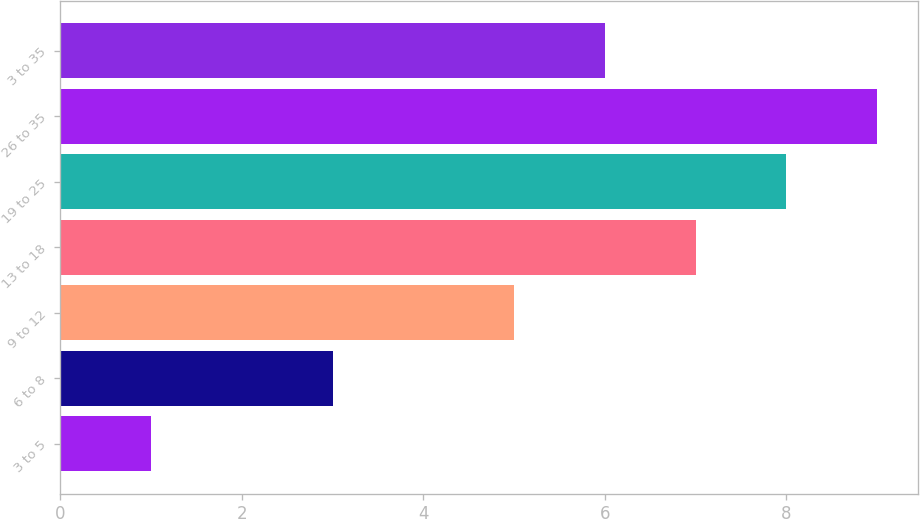<chart> <loc_0><loc_0><loc_500><loc_500><bar_chart><fcel>3 to 5<fcel>6 to 8<fcel>9 to 12<fcel>13 to 18<fcel>19 to 25<fcel>26 to 35<fcel>3 to 35<nl><fcel>1<fcel>3<fcel>5<fcel>7<fcel>8<fcel>9<fcel>6<nl></chart> 